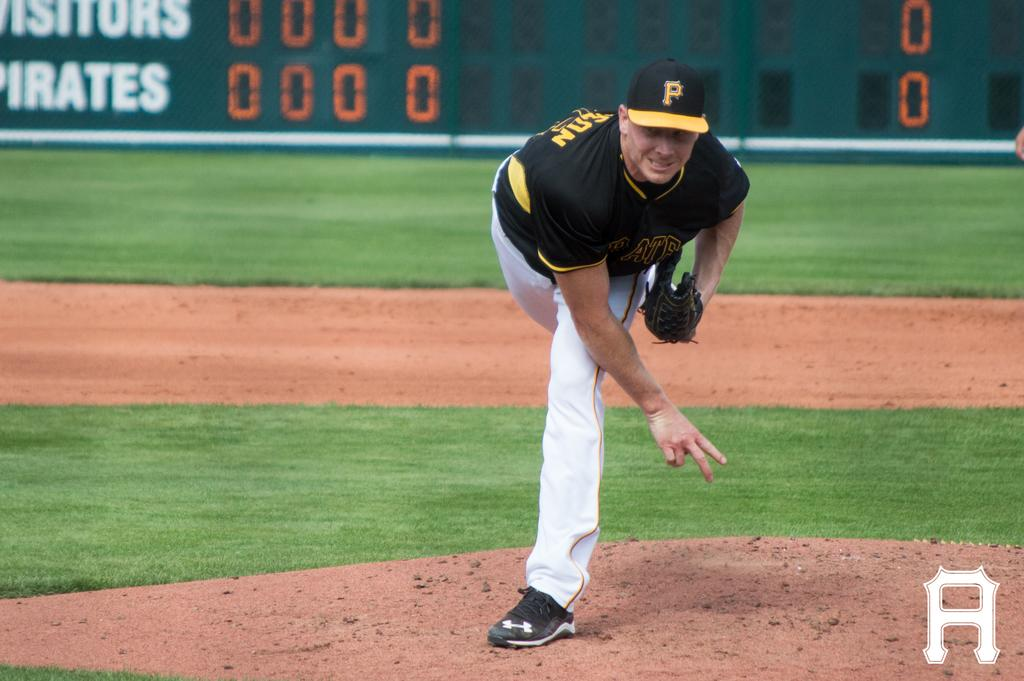<image>
Present a compact description of the photo's key features. A baseball player wearing a hat with an initial "P" throwing a baseball. 